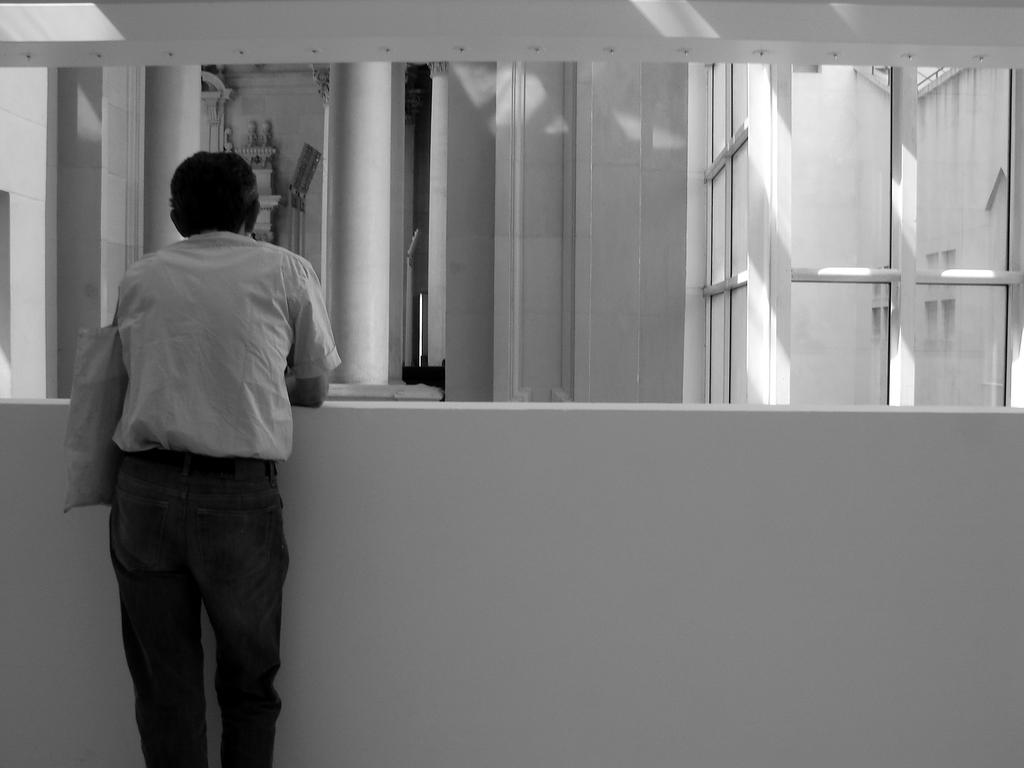What is the color scheme of the image? The image is black and white. What can be seen in the image besides the color scheme? There is a man standing in the image, and he is holding a bag. What architectural features are present in the image? There is a wall, pillars, and glass doors in the image. What type of trousers is the man wearing in the image? The image is black and white, so it is difficult to determine the type of trousers the man is wearing. Additionally, the provided facts do not mention any details about the man's clothing. How many heads of lettuce can be seen in the image? There are no heads of lettuce present in the image. 